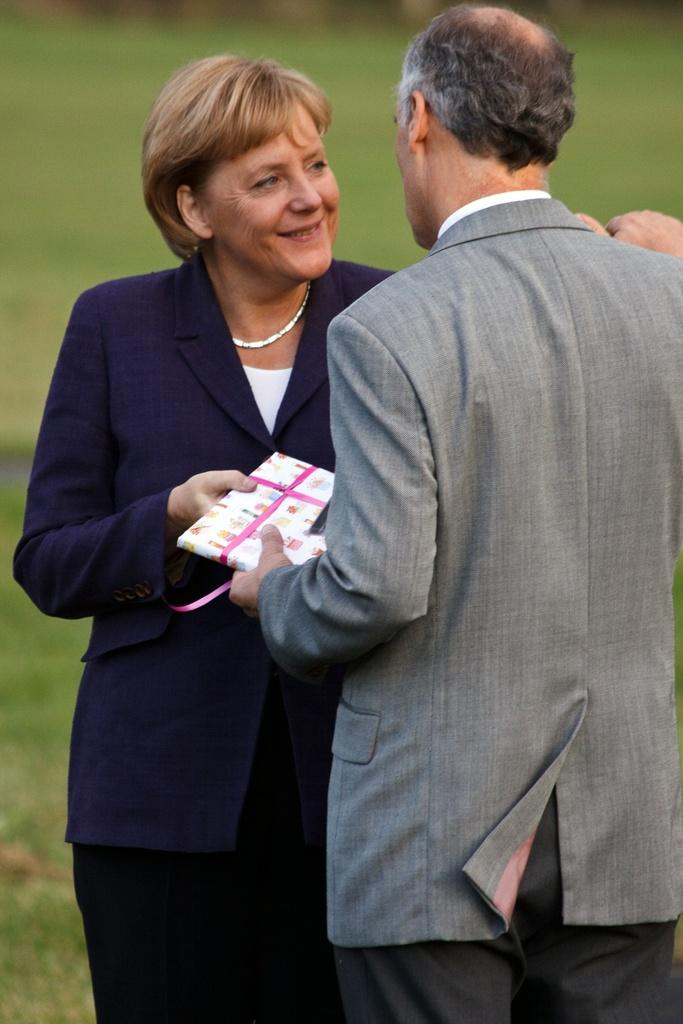What types of people are present in the image? There are women and men in the image. What are the people holding in the image? They are holding a gift pack. Can you describe the facial expression of one of the women? A woman is smiling in the image. How would you describe the background of the image? The background has a blurred view. What type of tank can be seen in the image? There is no tank present in the image. Is there a maid in the image? The image does not depict a maid. What is the woman holding in the image besides the gift pack? The woman is not holding anything else besides the gift pack in the image. 